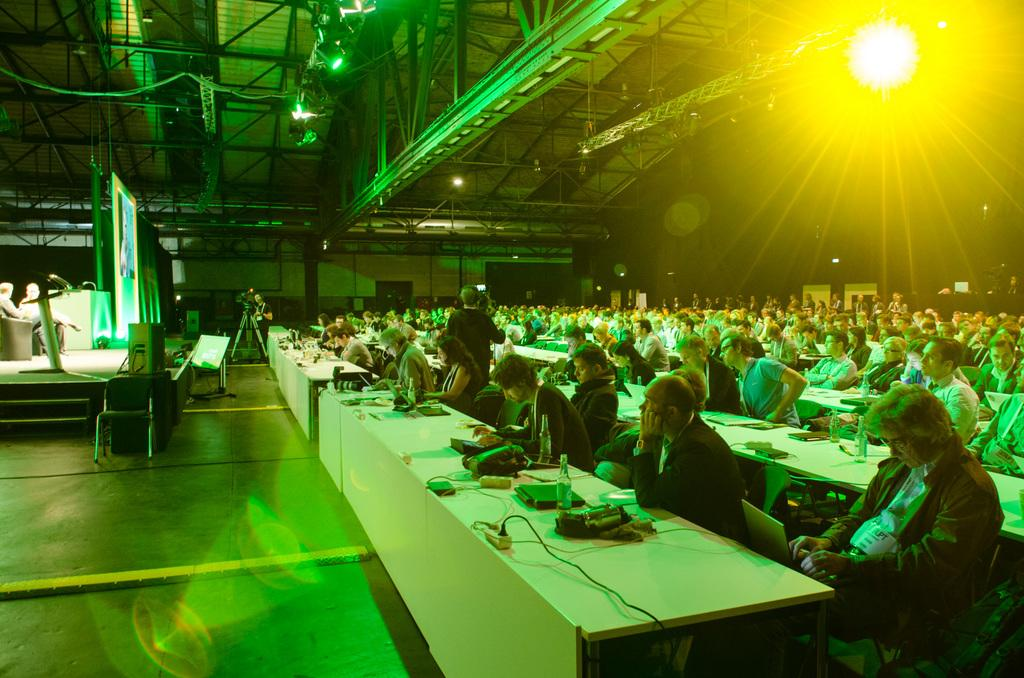What are the people in the image doing? There is a group of people sitting on chairs in the image. What objects can be seen on the table? There is a laptop and a bottle on the table in the image. What is in front of the group of people? There is a camera and a screen in front of the group. What type of arm is visible in the image? There is no arm visible in the image. How many weeks have passed since the event in the image occurred? The image does not provide any information about the time that has passed since the event occurred. 